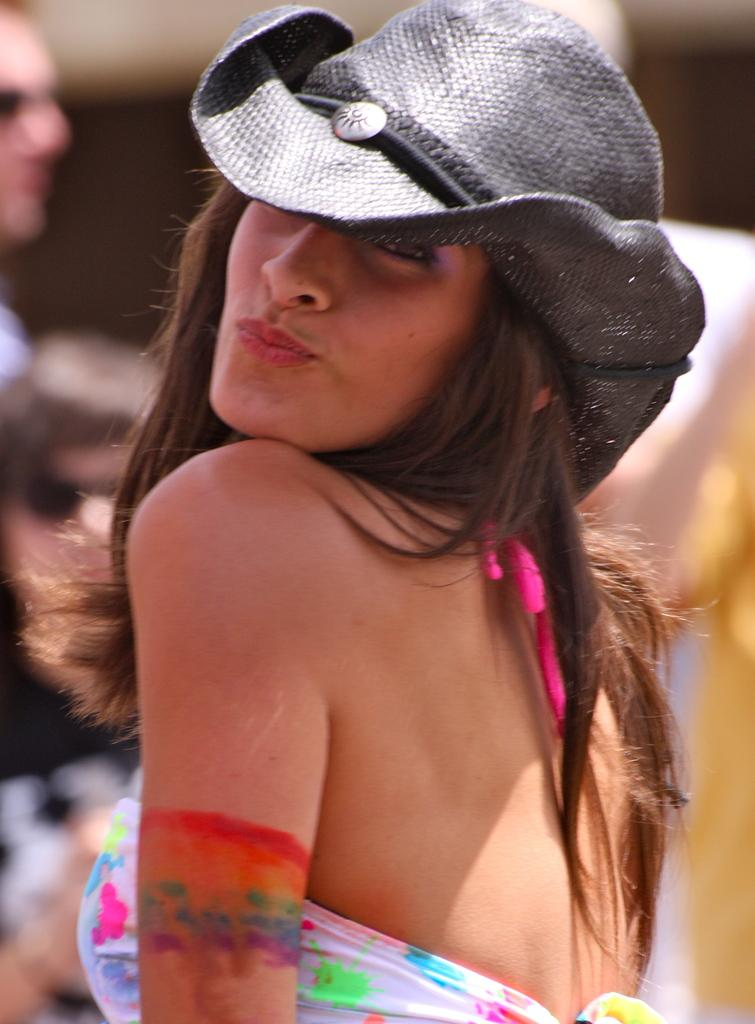Who is the main subject in the image? There is a girl in the image. What is the girl wearing on her head? The girl is wearing a black hat. How many grapes are hanging from the girl's hat in the image? There are no grapes present in the image, and therefore no grapes can be seen hanging from the girl's hat. 